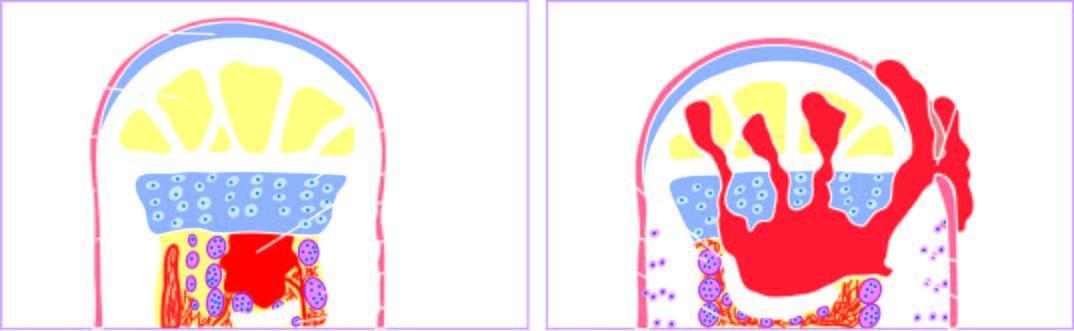does the abscess expand further causing necrosis of the cortex called sequestrum?
Answer the question using a single word or phrase. Yes 